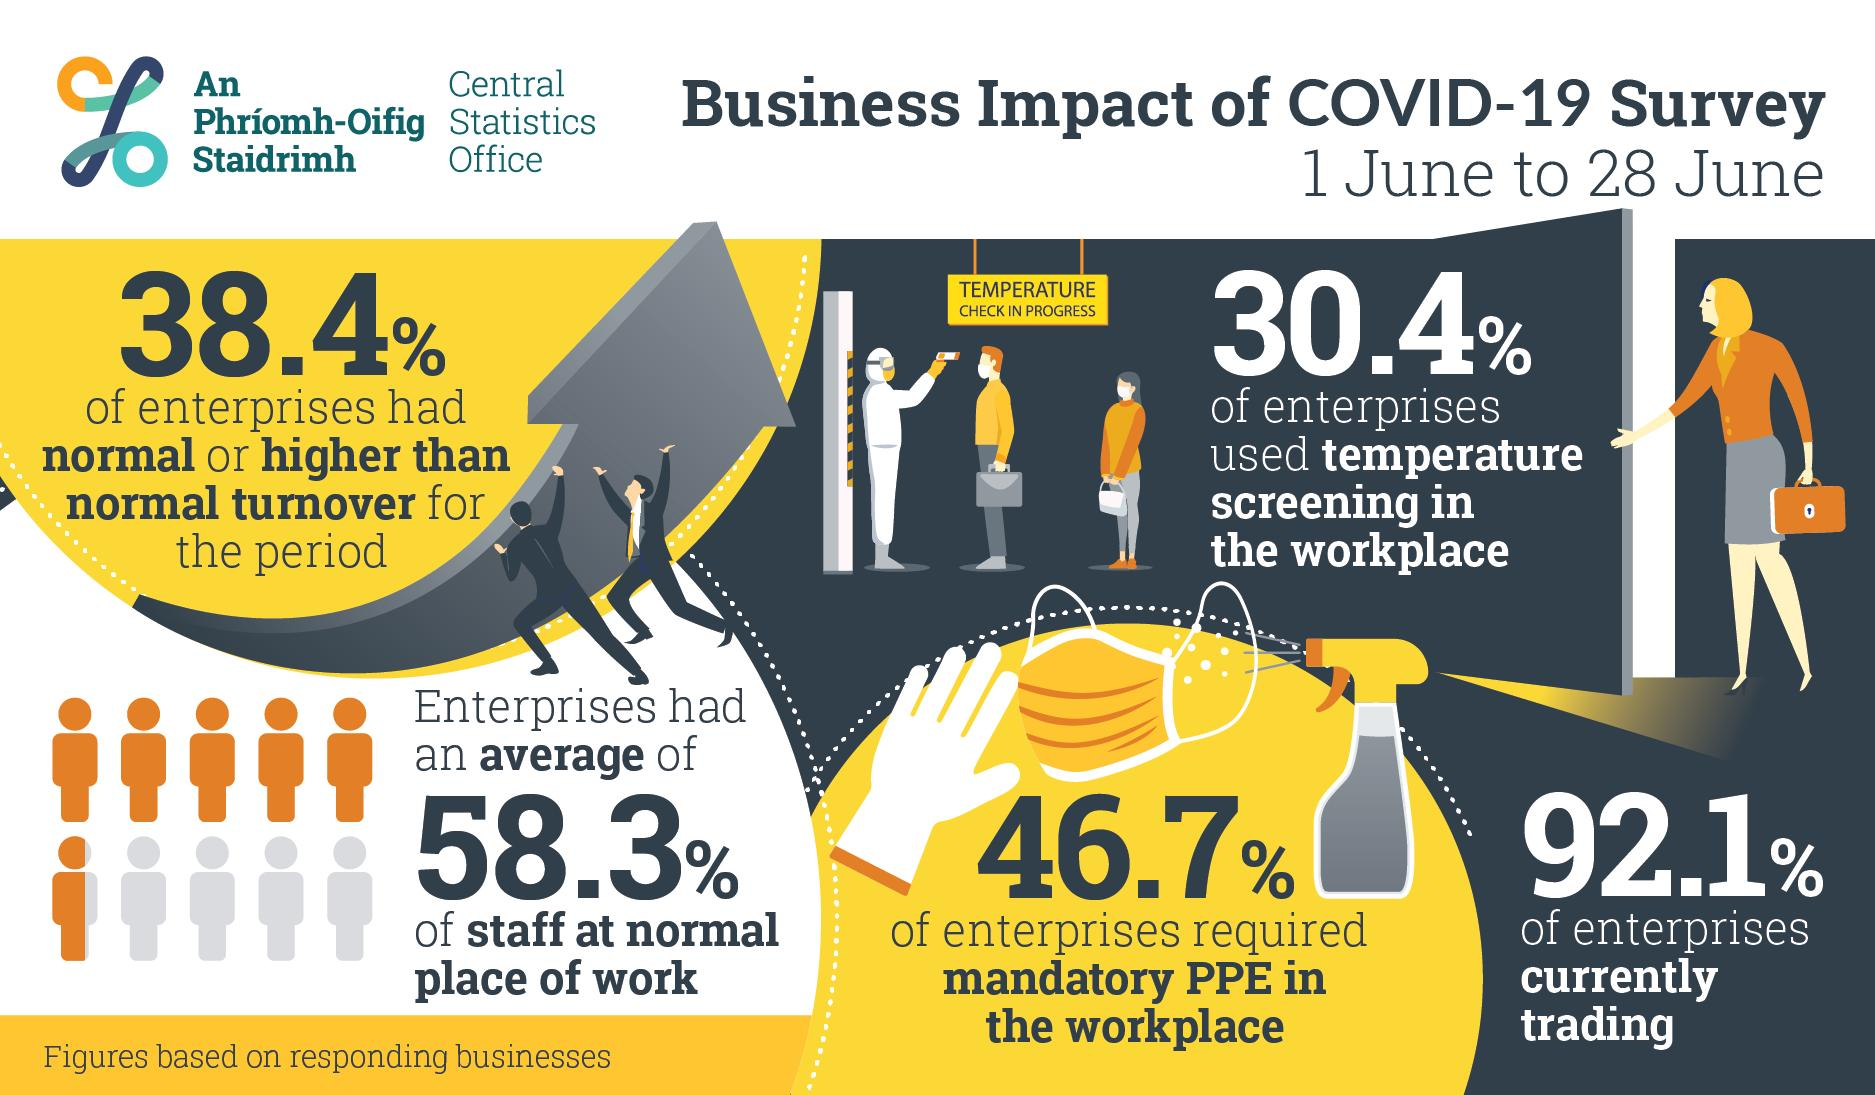Point out several critical features in this image. According to the Central Statistics Office Survey, 46.7% of enterprises required mandatory Personal Protective Equipment (PPE) in the workplace due to the impact of COVID-19. According to the Central Statistics Office Survey, 69.6% of the enterprises did not use temperature screening in the workplace. According to the Central Statistics Office Survey, 7.9% of enterprises were not currently trading due to the impact of COVID-19, indicating that the pandemic has had a significant impact on businesses. 